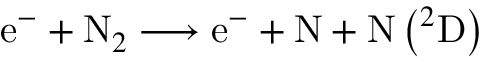Convert formula to latex. <formula><loc_0><loc_0><loc_500><loc_500>e ^ { - } + N _ { 2 } \longrightarrow e ^ { - } + N + N \left ^ { 2 } D \right )</formula> 